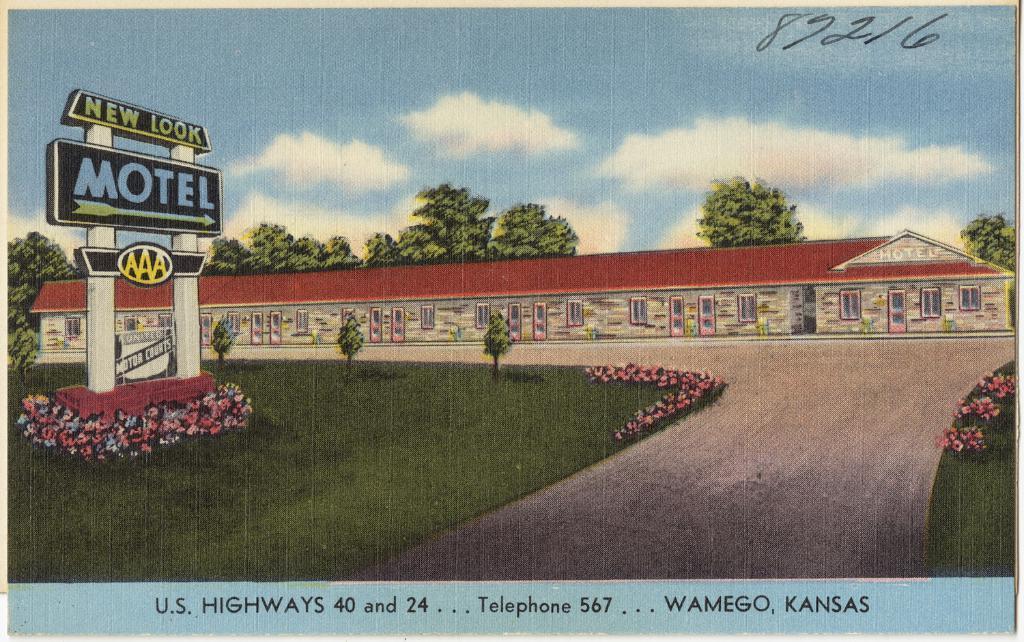Could you give a brief overview of what you see in this image? In this image I can see a board which is in black color attached to the pillar, background I can see a building in red and white color, trees in green color and the sky is in blue and white color. 